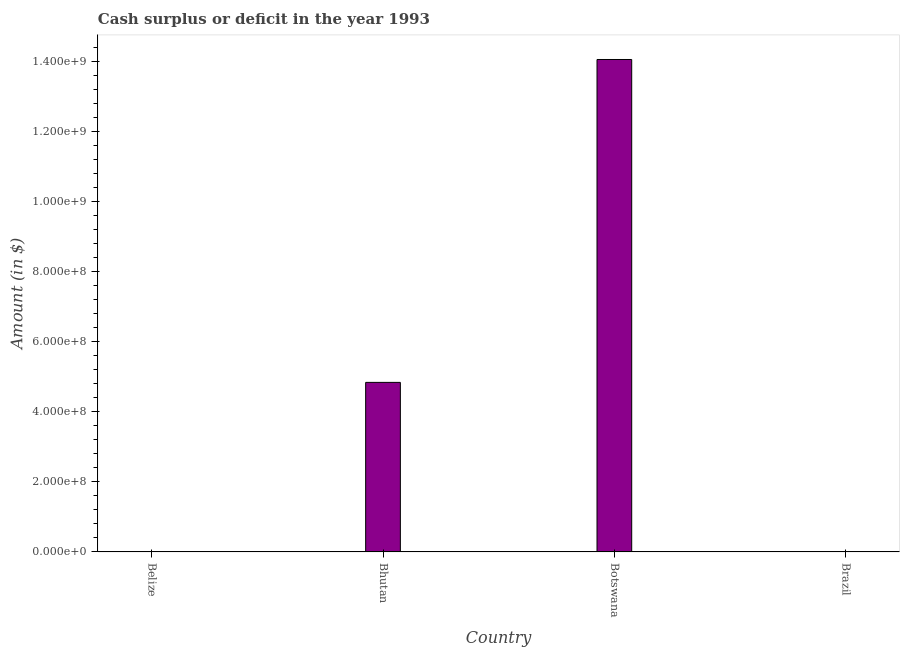Does the graph contain grids?
Your response must be concise. No. What is the title of the graph?
Your response must be concise. Cash surplus or deficit in the year 1993. What is the label or title of the X-axis?
Provide a succinct answer. Country. What is the label or title of the Y-axis?
Offer a very short reply. Amount (in $). What is the cash surplus or deficit in Belize?
Provide a short and direct response. 0. Across all countries, what is the maximum cash surplus or deficit?
Offer a terse response. 1.40e+09. Across all countries, what is the minimum cash surplus or deficit?
Offer a terse response. 0. In which country was the cash surplus or deficit maximum?
Make the answer very short. Botswana. What is the sum of the cash surplus or deficit?
Give a very brief answer. 1.89e+09. What is the difference between the cash surplus or deficit in Bhutan and Botswana?
Your response must be concise. -9.21e+08. What is the average cash surplus or deficit per country?
Offer a terse response. 4.72e+08. What is the median cash surplus or deficit?
Provide a short and direct response. 2.42e+08. What is the ratio of the cash surplus or deficit in Bhutan to that in Botswana?
Provide a short and direct response. 0.34. What is the difference between the highest and the lowest cash surplus or deficit?
Offer a very short reply. 1.40e+09. In how many countries, is the cash surplus or deficit greater than the average cash surplus or deficit taken over all countries?
Offer a very short reply. 2. How many bars are there?
Your answer should be very brief. 2. Are all the bars in the graph horizontal?
Ensure brevity in your answer.  No. What is the difference between two consecutive major ticks on the Y-axis?
Offer a terse response. 2.00e+08. What is the Amount (in $) in Bhutan?
Provide a succinct answer. 4.84e+08. What is the Amount (in $) of Botswana?
Make the answer very short. 1.40e+09. What is the Amount (in $) in Brazil?
Your answer should be very brief. 0. What is the difference between the Amount (in $) in Bhutan and Botswana?
Provide a succinct answer. -9.21e+08. What is the ratio of the Amount (in $) in Bhutan to that in Botswana?
Make the answer very short. 0.34. 